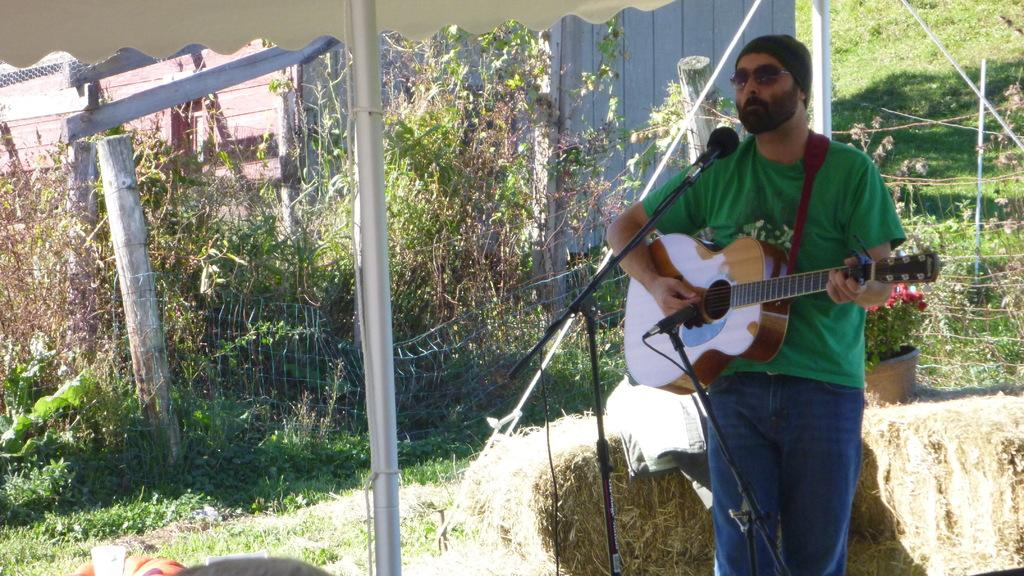What is the man in the image doing? The man is playing a guitar. What object is the man positioned in front of? The man is in front of a microphone. What can be seen in the background of the image? There are small trees in the background of the image. What idea does the man have for the next song he will play on the guitar? There is no information in the image about the man's ideas for his next song. How does the man blow into the microphone while playing the guitar? The man is not blowing into the microphone in the image; he is simply standing in front of it while playing the guitar. 